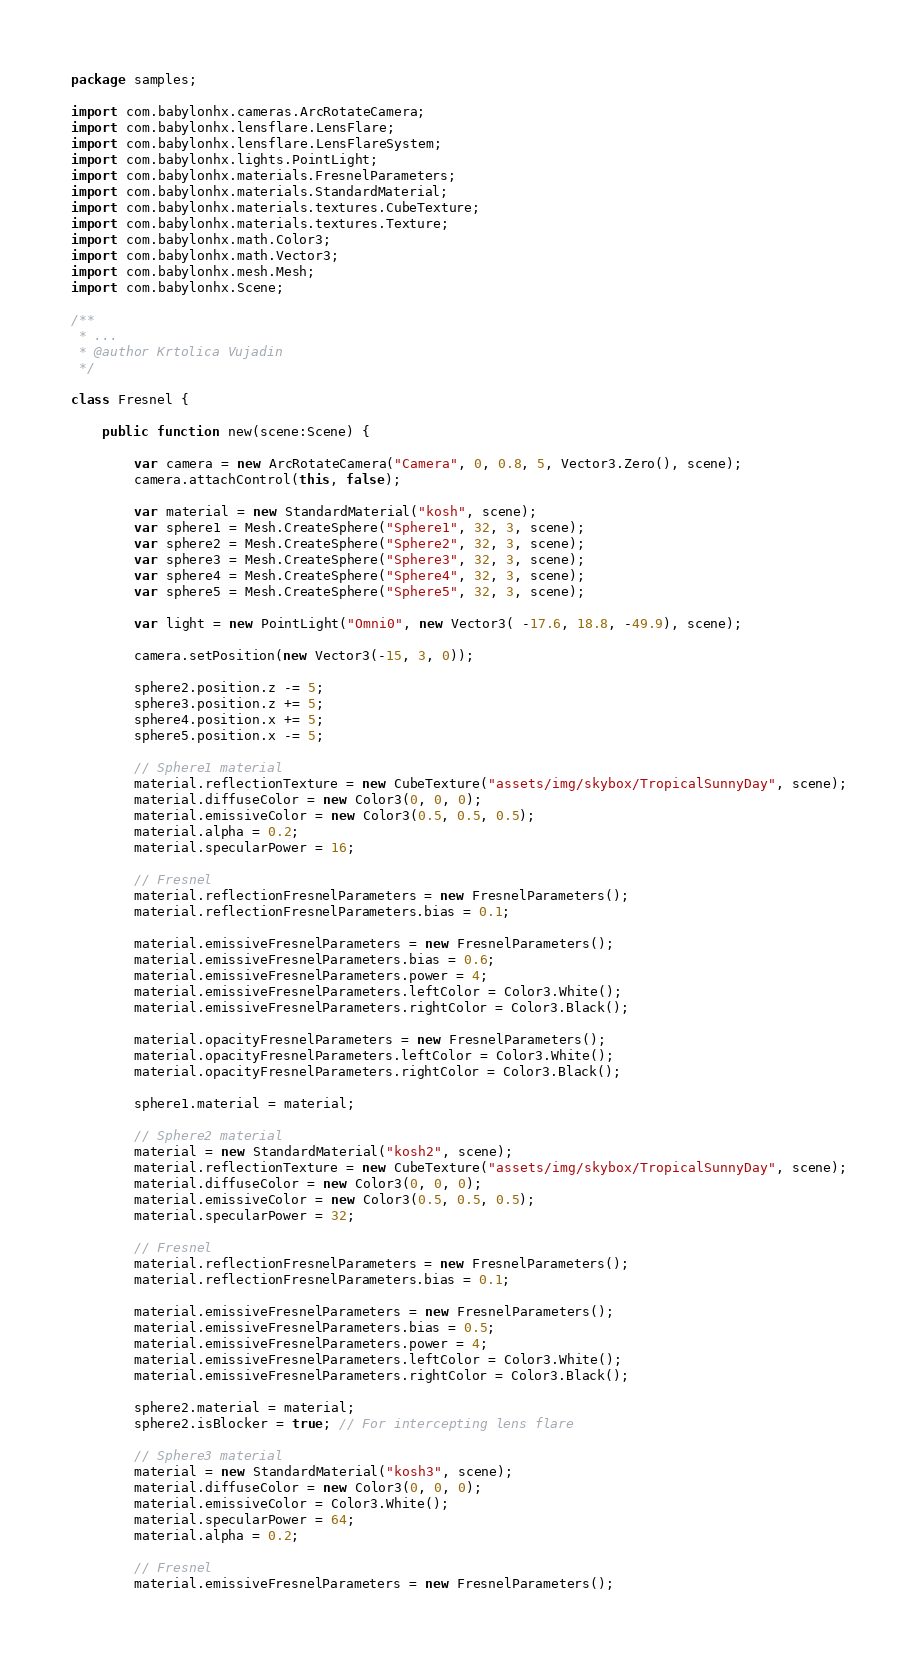<code> <loc_0><loc_0><loc_500><loc_500><_Haxe_>package samples;

import com.babylonhx.cameras.ArcRotateCamera;
import com.babylonhx.lensflare.LensFlare;
import com.babylonhx.lensflare.LensFlareSystem;
import com.babylonhx.lights.PointLight;
import com.babylonhx.materials.FresnelParameters;
import com.babylonhx.materials.StandardMaterial;
import com.babylonhx.materials.textures.CubeTexture;
import com.babylonhx.materials.textures.Texture;
import com.babylonhx.math.Color3;
import com.babylonhx.math.Vector3;
import com.babylonhx.mesh.Mesh;
import com.babylonhx.Scene;

/**
 * ...
 * @author Krtolica Vujadin
 */

class Fresnel {
	
	public function new(scene:Scene) {
		
		var camera = new ArcRotateCamera("Camera", 0, 0.8, 5, Vector3.Zero(), scene);
		camera.attachControl(this, false);
		
		var material = new StandardMaterial("kosh", scene);
		var sphere1 = Mesh.CreateSphere("Sphere1", 32, 3, scene);
		var sphere2 = Mesh.CreateSphere("Sphere2", 32, 3, scene);
		var sphere3 = Mesh.CreateSphere("Sphere3", 32, 3, scene);
		var sphere4 = Mesh.CreateSphere("Sphere4", 32, 3, scene);
		var sphere5 = Mesh.CreateSphere("Sphere5", 32, 3, scene);
		
		var light = new PointLight("Omni0", new Vector3( -17.6, 18.8, -49.9), scene);
		
		camera.setPosition(new Vector3(-15, 3, 0));
		
		sphere2.position.z -= 5;
		sphere3.position.z += 5;
		sphere4.position.x += 5;
		sphere5.position.x -= 5;
		
		// Sphere1 material
		material.reflectionTexture = new CubeTexture("assets/img/skybox/TropicalSunnyDay", scene);
		material.diffuseColor = new Color3(0, 0, 0);
		material.emissiveColor = new Color3(0.5, 0.5, 0.5);
		material.alpha = 0.2;
		material.specularPower = 16;
		
		// Fresnel
		material.reflectionFresnelParameters = new FresnelParameters();
		material.reflectionFresnelParameters.bias = 0.1;
		
		material.emissiveFresnelParameters = new FresnelParameters();
		material.emissiveFresnelParameters.bias = 0.6;
		material.emissiveFresnelParameters.power = 4;
		material.emissiveFresnelParameters.leftColor = Color3.White();
		material.emissiveFresnelParameters.rightColor = Color3.Black();
		
		material.opacityFresnelParameters = new FresnelParameters();
		material.opacityFresnelParameters.leftColor = Color3.White();
		material.opacityFresnelParameters.rightColor = Color3.Black();
		
		sphere1.material = material;
		
		// Sphere2 material
		material = new StandardMaterial("kosh2", scene);
		material.reflectionTexture = new CubeTexture("assets/img/skybox/TropicalSunnyDay", scene);
		material.diffuseColor = new Color3(0, 0, 0);
		material.emissiveColor = new Color3(0.5, 0.5, 0.5);
		material.specularPower = 32;
		
		// Fresnel
		material.reflectionFresnelParameters = new FresnelParameters();
		material.reflectionFresnelParameters.bias = 0.1;
		
		material.emissiveFresnelParameters = new FresnelParameters();
		material.emissiveFresnelParameters.bias = 0.5;
		material.emissiveFresnelParameters.power = 4;
		material.emissiveFresnelParameters.leftColor = Color3.White();
		material.emissiveFresnelParameters.rightColor = Color3.Black();
		
		sphere2.material = material;
		sphere2.isBlocker = true; // For intercepting lens flare
		
		// Sphere3 material
		material = new StandardMaterial("kosh3", scene);
		material.diffuseColor = new Color3(0, 0, 0);
		material.emissiveColor = Color3.White();
		material.specularPower = 64;
		material.alpha = 0.2;
		
		// Fresnel
		material.emissiveFresnelParameters = new FresnelParameters();</code> 